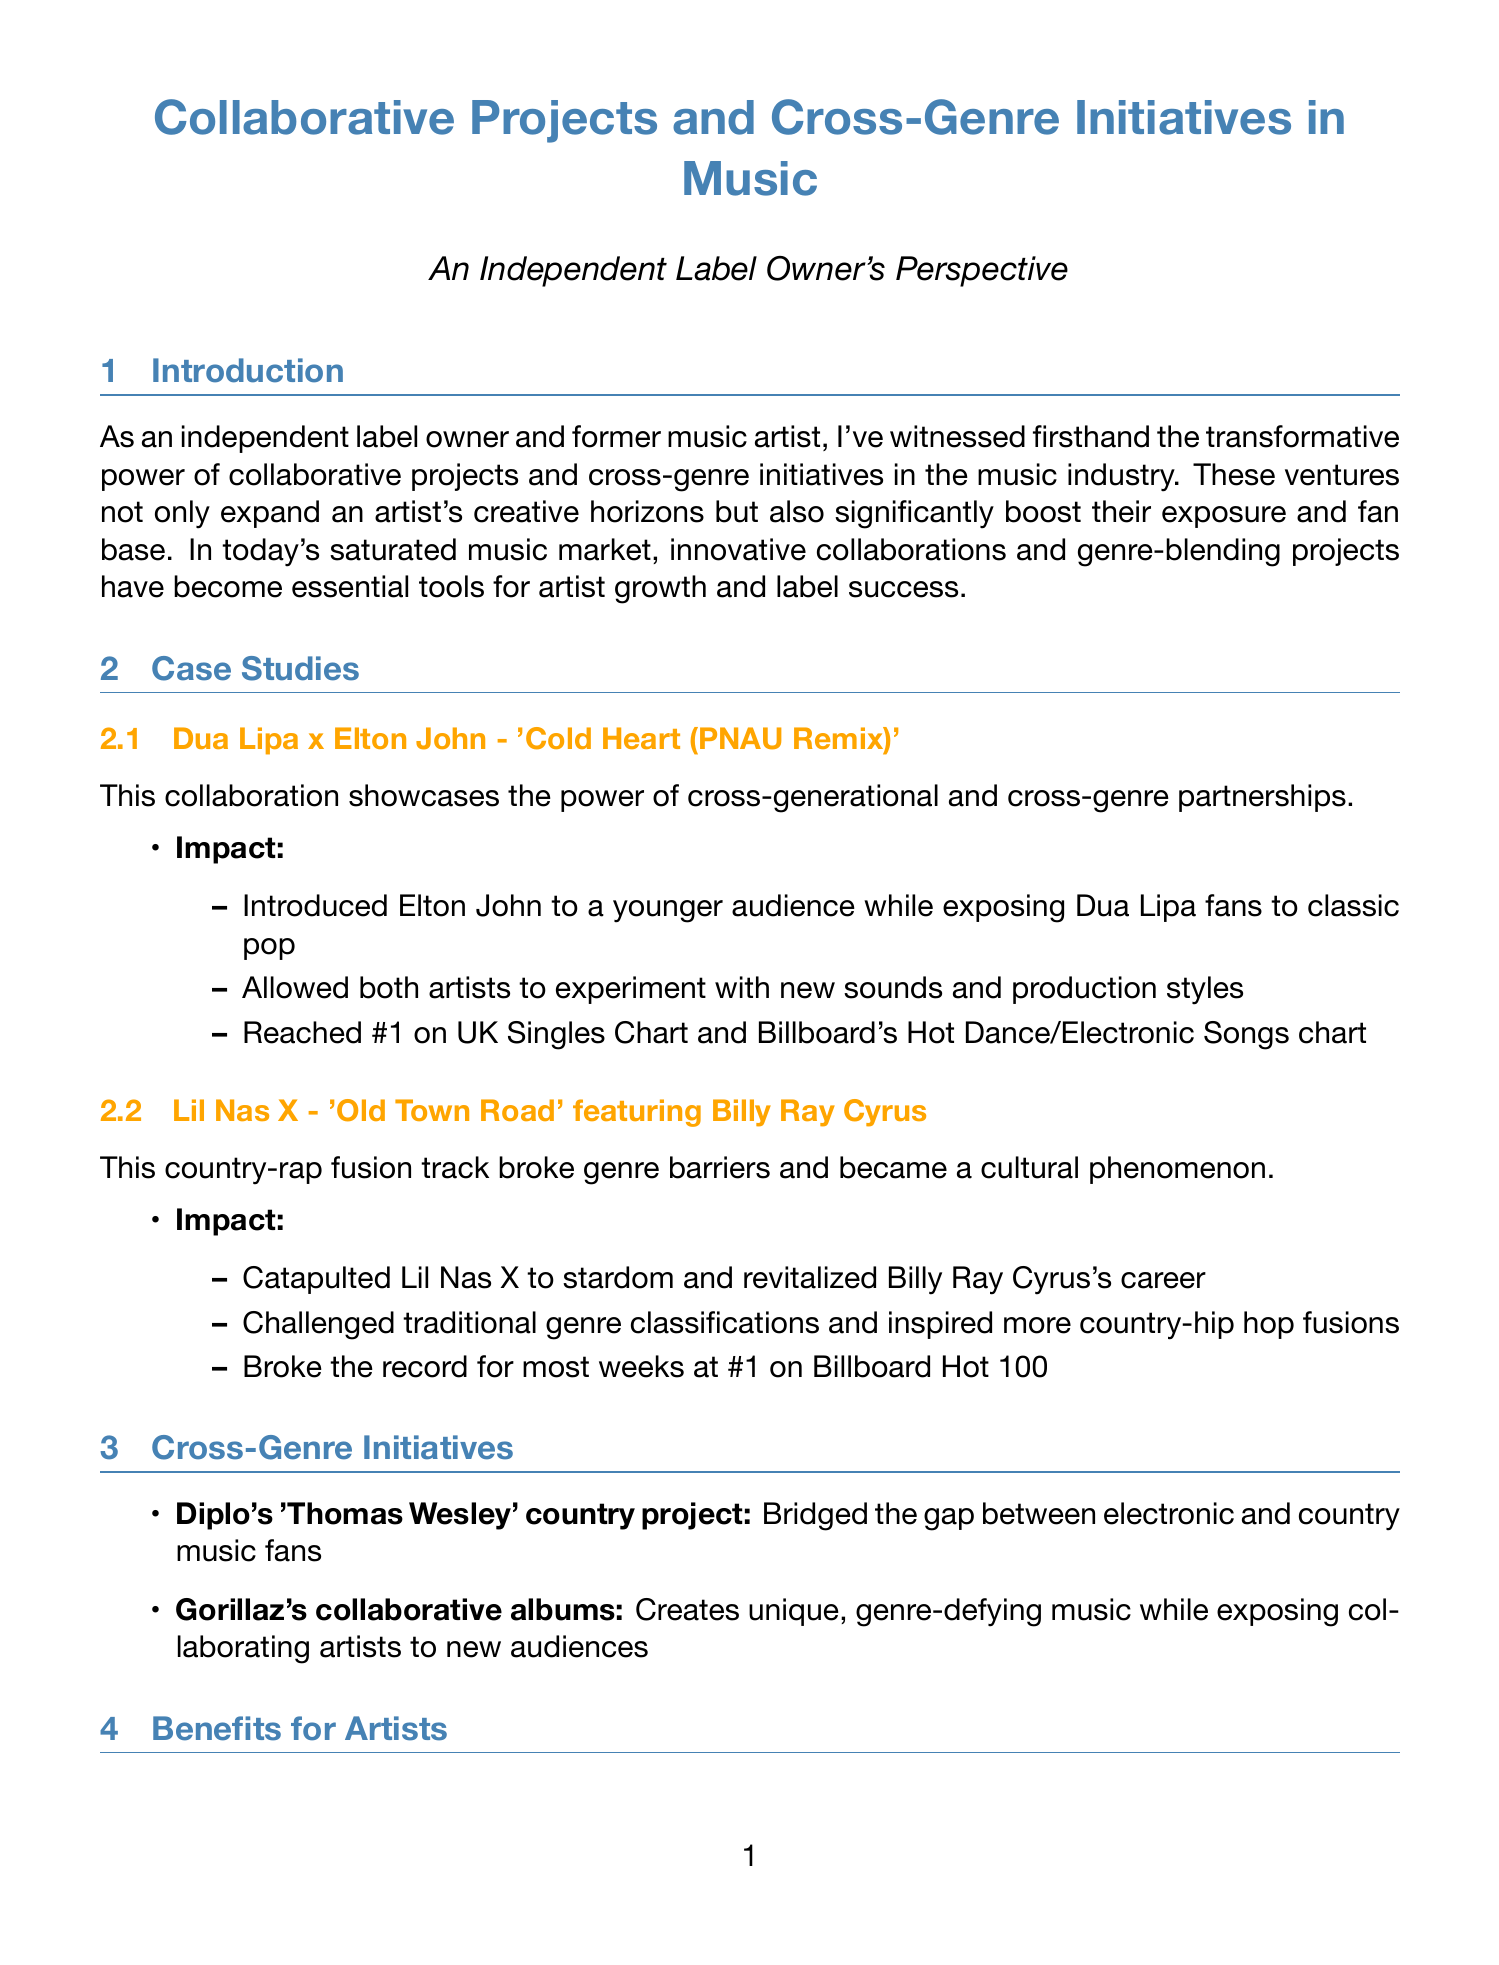What is the primary purpose of collaborative projects? The document states that these ventures expand an artist's creative horizons and significantly boost their exposure and fan base.
Answer: Expand artists' creative horizons and boost exposure Who collaborated with Dua Lipa on the song 'Cold Heart'? The document mentions that Elton John collaborated with Dua Lipa on this song.
Answer: Elton John What is one benefit for artists mentioned in the document? The document lists several benefits, and one of them is exposure to new fan bases.
Answer: Exposure to new fan bases What technological trend is anticipated in future cross-genre initiatives? The document discusses trends, including the use of artificial intelligence for music creation.
Answer: AI-assisted cross-genre music creation What was a significant commercial success of 'Old Town Road'? According to the document, it broke the record for most weeks at number one on Billboard Hot 100.
Answer: Most weeks at #1 on Billboard Hot 100 What challenge do artists face in collaborations? The document lists challenges, including maintaining artistic integrity while appealing to different audiences.
Answer: Maintaining artistic integrity How does the document describe Diplo's country project? It is described as bridging the gap between electronic and country music fans.
Answer: Bridged the gap between electronic and country music fans What is one advantage for independent labels mentioned in the report? The document states that one advantage is the ability to punch above weight class through strategic collaborations.
Answer: Punch above weight class through strategic collaborations 